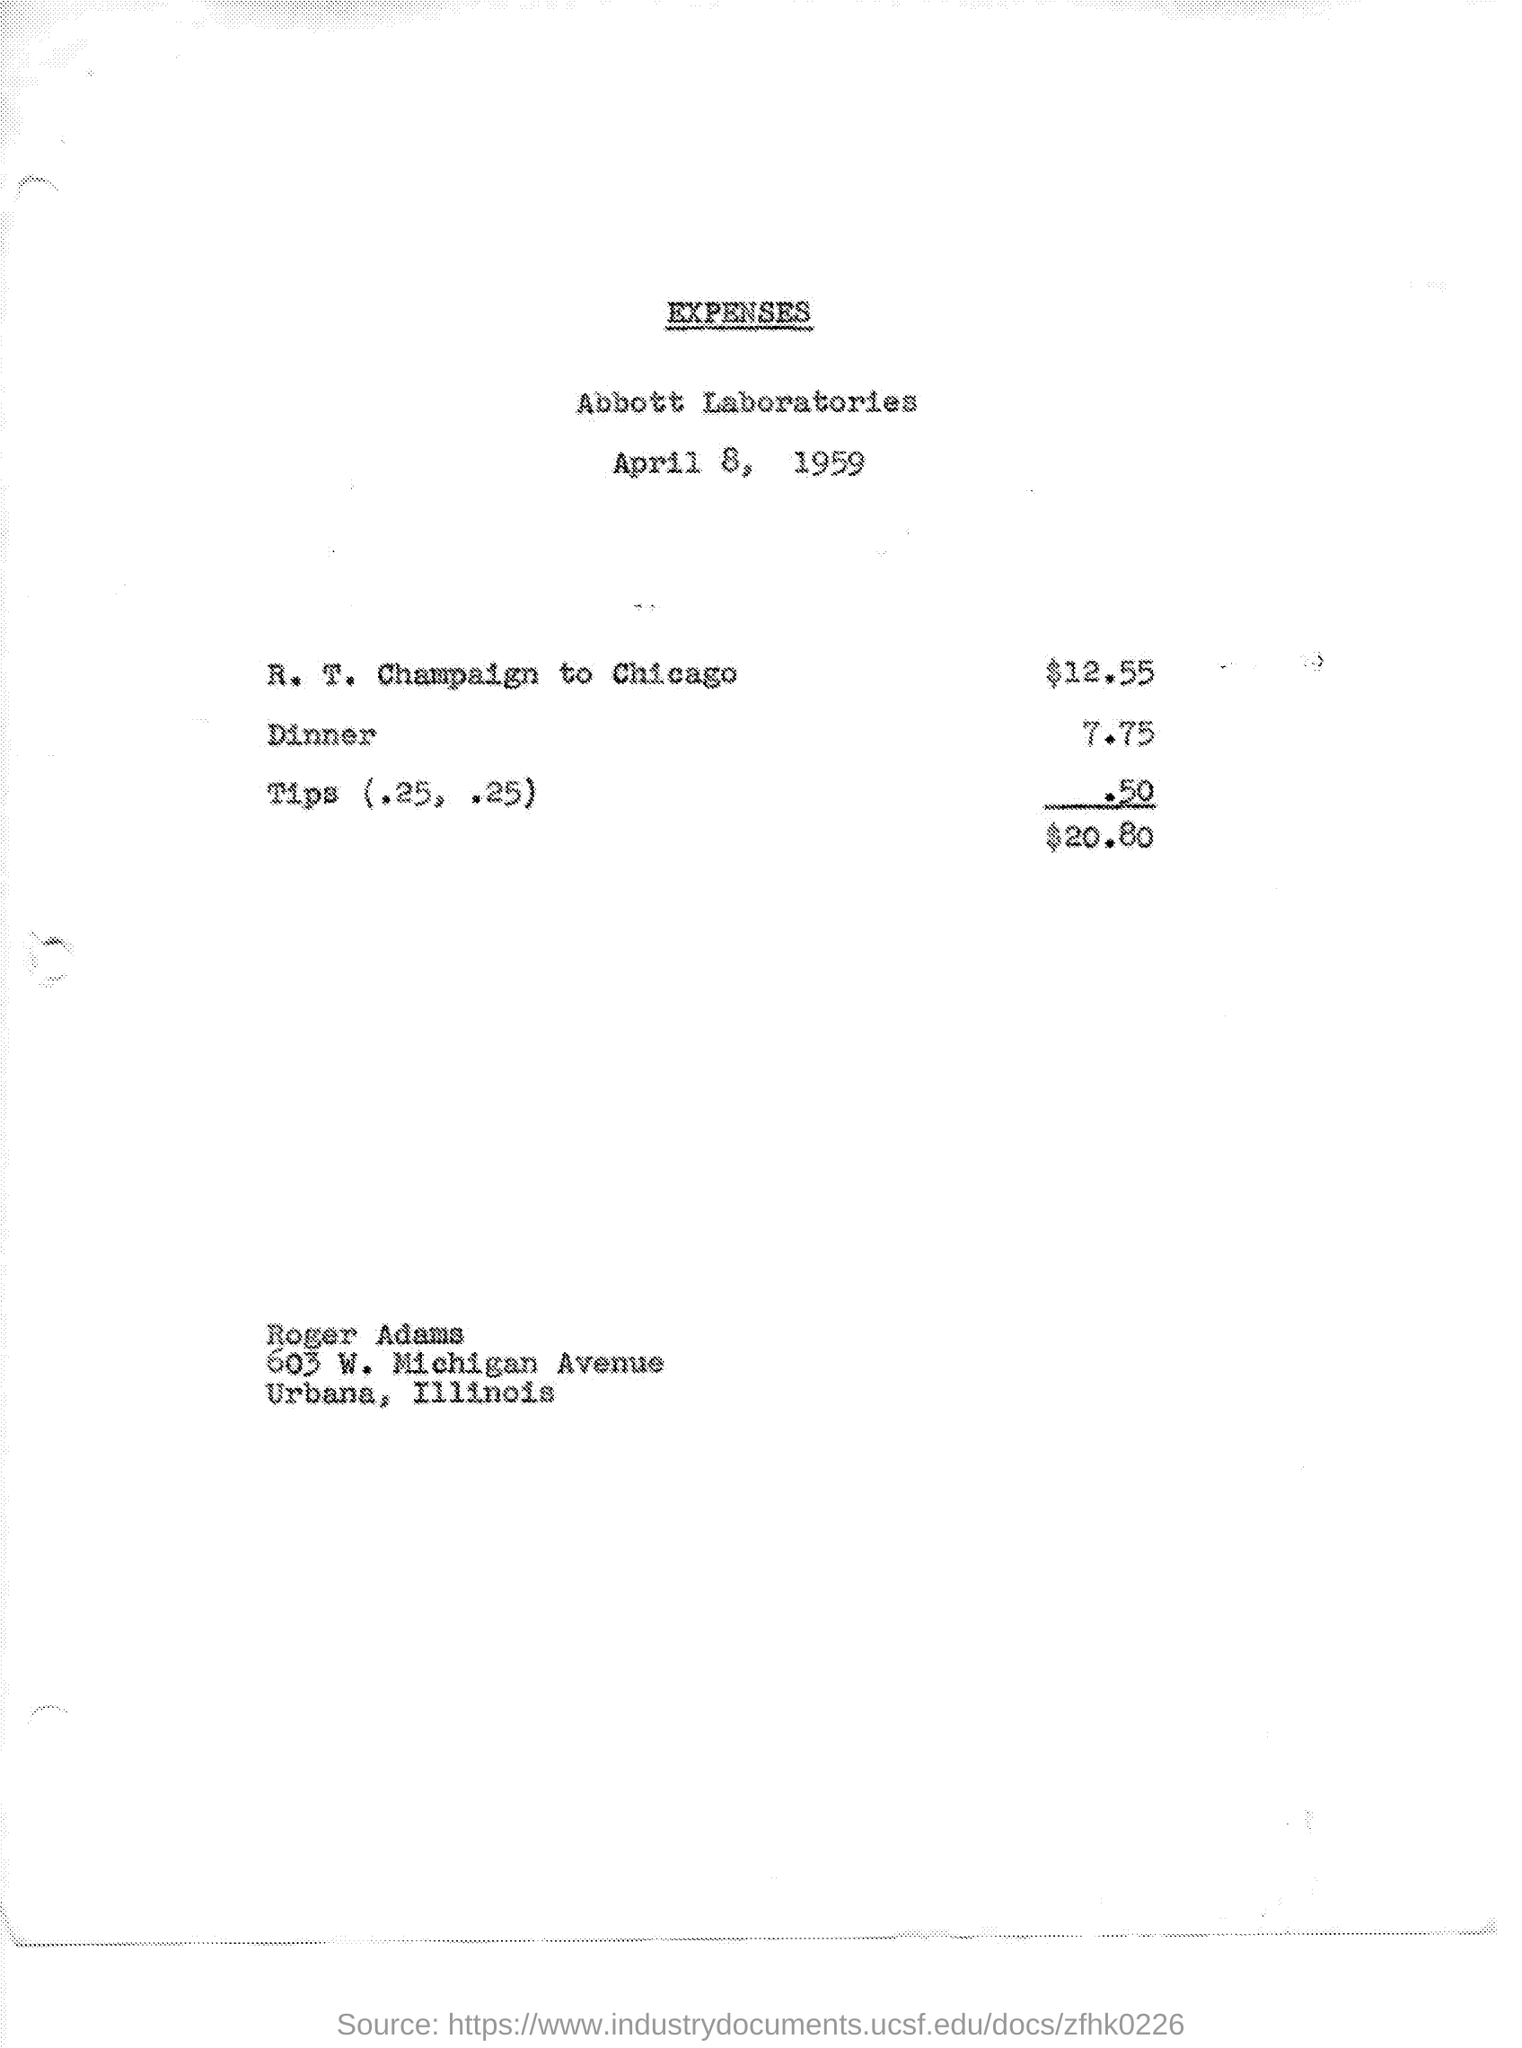Mention a couple of crucial points in this snapshot. The cost of a round-trip ticket from R.T. Champaign to Chicago is $12.55. The date mentioned in the given page is April 8, 1959. The person named Roger Adams is mentioned in the given page. The expenses for dinner mentioned on the given page are 7.75. The expenses for tips mentioned in the given page are .50. 